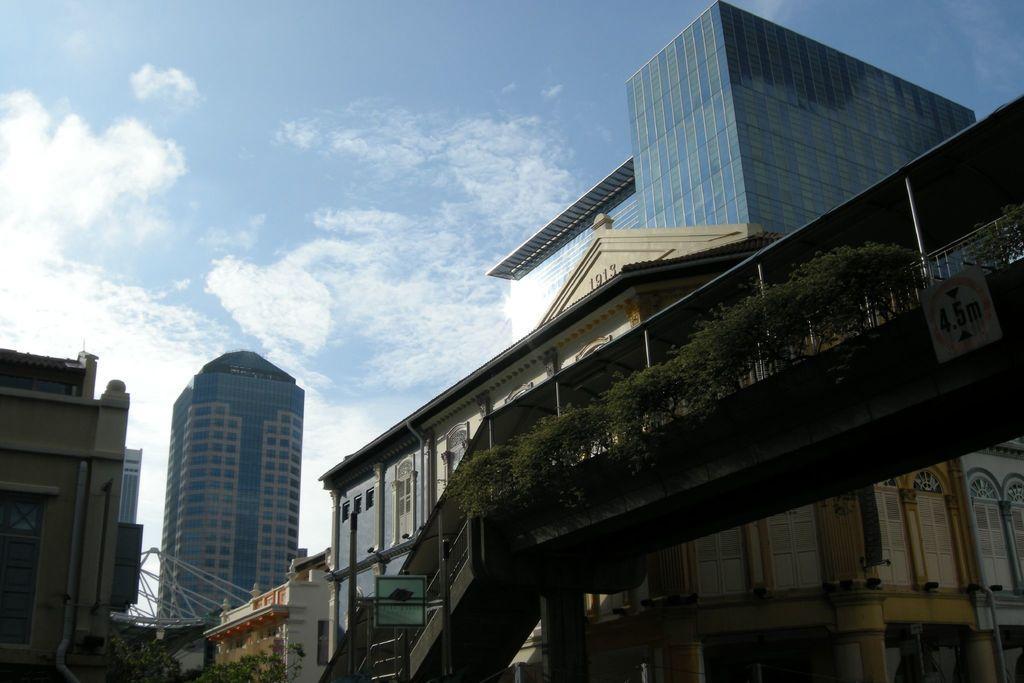Can you describe this image briefly? In this picture, on the right side, we can see a bridge and plants. In the middle of the image, we can see a hoarding. On the left side, we can see a building. In the background, we can see some buildings, houses, plants. On the top, we can see a sky. 